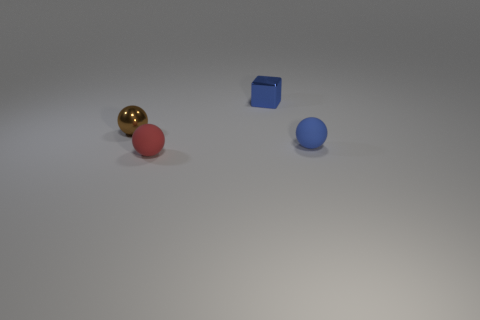There is a small sphere that is the same color as the small block; what material is it?
Ensure brevity in your answer.  Rubber. Do the brown shiny object and the red matte thing have the same size?
Your answer should be compact. Yes. Are there the same number of tiny balls that are behind the tiny brown thing and small blue metal objects?
Ensure brevity in your answer.  No. There is a small blue object in front of the small block; are there any small red things behind it?
Keep it short and to the point. No. What is the size of the object in front of the blue thing right of the metal thing to the right of the tiny brown sphere?
Provide a short and direct response. Small. There is a sphere that is to the right of the ball in front of the tiny blue rubber thing; what is its material?
Make the answer very short. Rubber. Are there any tiny red things that have the same shape as the tiny blue shiny thing?
Give a very brief answer. No. What shape is the tiny brown metal object?
Ensure brevity in your answer.  Sphere. The blue object in front of the small shiny object to the left of the tiny blue object behind the small blue sphere is made of what material?
Your answer should be compact. Rubber. Is the number of blue blocks right of the tiny blue matte ball greater than the number of tiny gray matte balls?
Keep it short and to the point. No. 